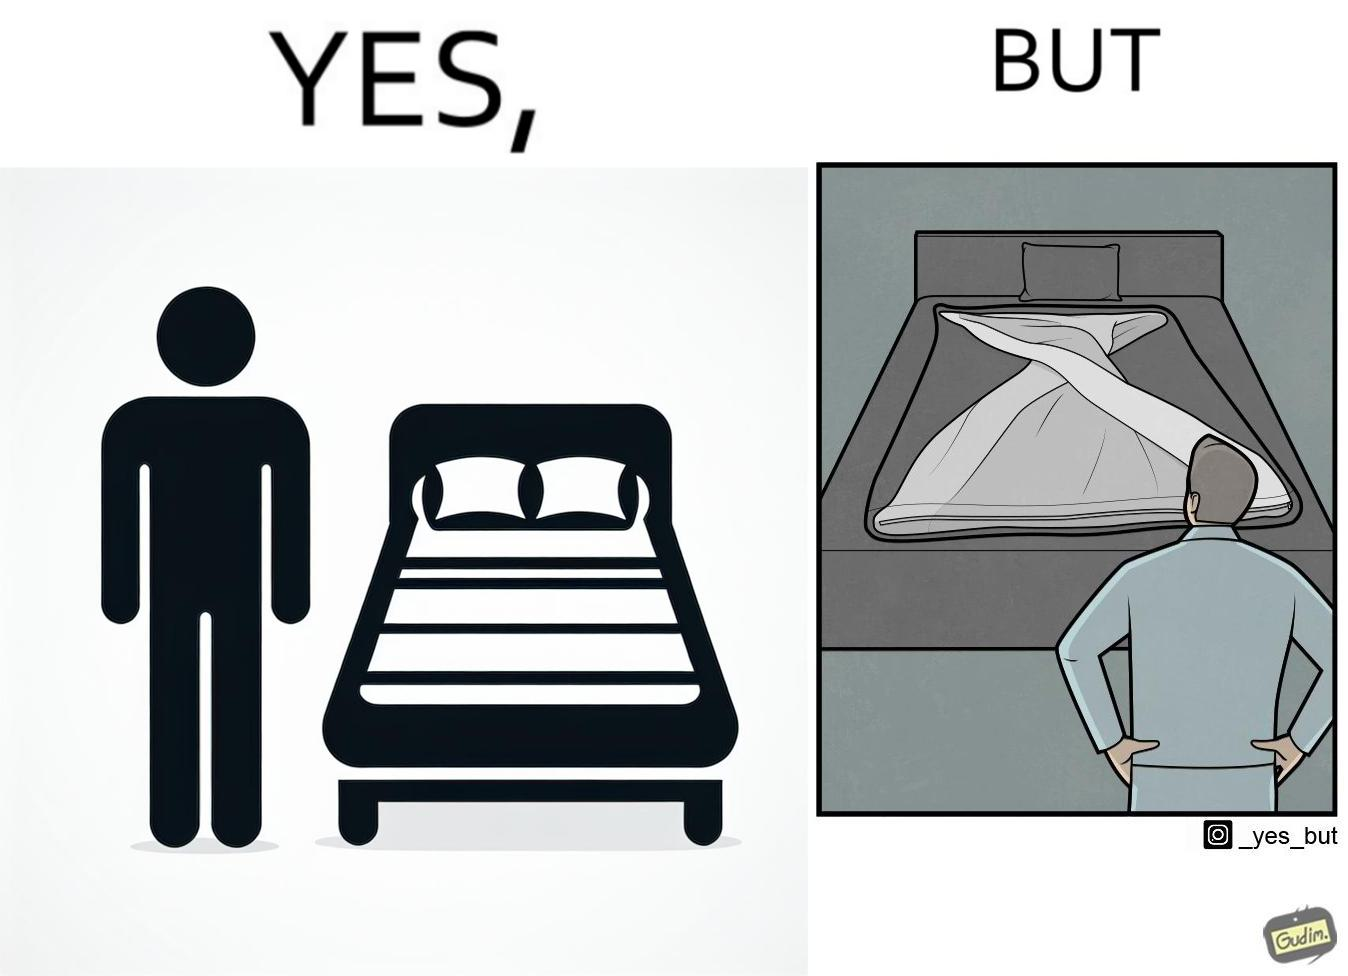What is shown in the left half versus the right half of this image? In the left part of the image: The image shows a man looking at his bed. His bed seems well made with blanket and pillow properly arranged on the mattress. In the right part of the image: The image shows a man looking at his bed. The image also shows the actual blanket inside its cover on the bed. The blanked is all twisted inside the cover and is not properly set. 